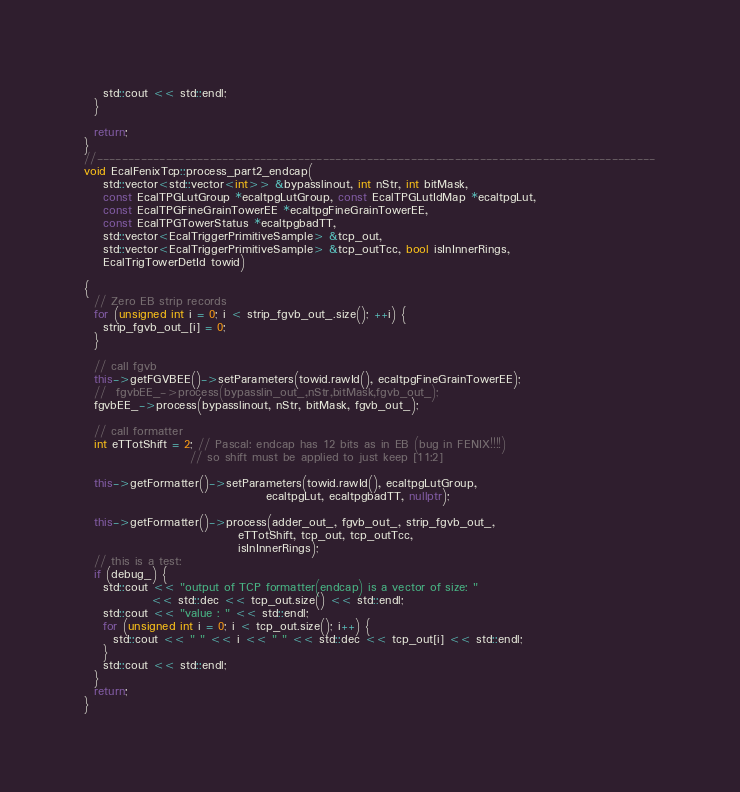<code> <loc_0><loc_0><loc_500><loc_500><_C++_>    std::cout << std::endl;
  }

  return;
}
//-----------------------------------------------------------------------------------------
void EcalFenixTcp::process_part2_endcap(
    std::vector<std::vector<int>> &bypasslinout, int nStr, int bitMask,
    const EcalTPGLutGroup *ecaltpgLutGroup, const EcalTPGLutIdMap *ecaltpgLut,
    const EcalTPGFineGrainTowerEE *ecaltpgFineGrainTowerEE,
    const EcalTPGTowerStatus *ecaltpgbadTT,
    std::vector<EcalTriggerPrimitiveSample> &tcp_out,
    std::vector<EcalTriggerPrimitiveSample> &tcp_outTcc, bool isInInnerRings,
    EcalTrigTowerDetId towid)

{
  // Zero EB strip records
  for (unsigned int i = 0; i < strip_fgvb_out_.size(); ++i) {
    strip_fgvb_out_[i] = 0;
  }

  // call fgvb
  this->getFGVBEE()->setParameters(towid.rawId(), ecaltpgFineGrainTowerEE);
  //  fgvbEE_->process(bypasslin_out_,nStr,bitMask,fgvb_out_);
  fgvbEE_->process(bypasslinout, nStr, bitMask, fgvb_out_);

  // call formatter
  int eTTotShift = 2; // Pascal: endcap has 12 bits as in EB (bug in FENIX!!!!)
                      // so shift must be applied to just keep [11:2]

  this->getFormatter()->setParameters(towid.rawId(), ecaltpgLutGroup,
                                      ecaltpgLut, ecaltpgbadTT, nullptr);

  this->getFormatter()->process(adder_out_, fgvb_out_, strip_fgvb_out_,
                                eTTotShift, tcp_out, tcp_outTcc,
                                isInInnerRings);
  // this is a test:
  if (debug_) {
    std::cout << "output of TCP formatter(endcap) is a vector of size: "
              << std::dec << tcp_out.size() << std::endl;
    std::cout << "value : " << std::endl;
    for (unsigned int i = 0; i < tcp_out.size(); i++) {
      std::cout << " " << i << " " << std::dec << tcp_out[i] << std::endl;
    }
    std::cout << std::endl;
  }
  return;
}
</code> 